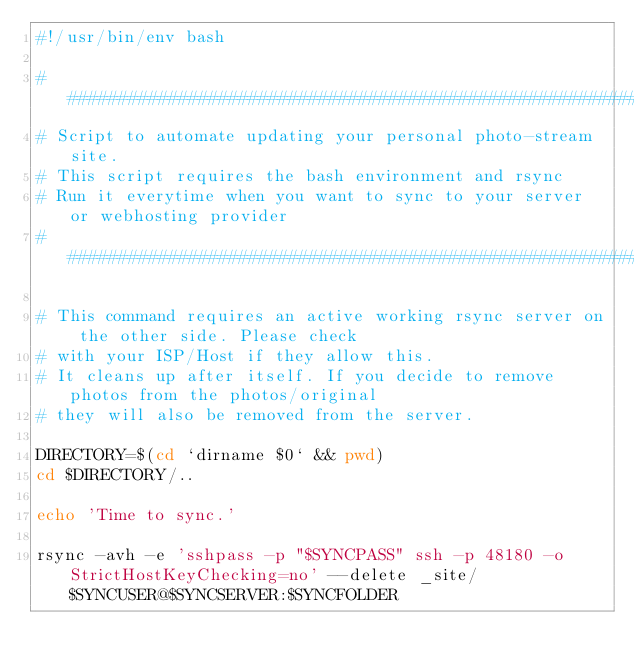<code> <loc_0><loc_0><loc_500><loc_500><_Bash_>#!/usr/bin/env bash

#####################################################################################
# Script to automate updating your personal photo-stream site.
# This script requires the bash environment and rsync
# Run it everytime when you want to sync to your server or webhosting provider
#####################################################################################

# This command requires an active working rsync server on the other side. Please check 
# with your ISP/Host if they allow this.
# It cleans up after itself. If you decide to remove photos from the photos/original
# they will also be removed from the server.

DIRECTORY=$(cd `dirname $0` && pwd)
cd $DIRECTORY/..

echo 'Time to sync.'

rsync -avh -e 'sshpass -p "$SYNCPASS" ssh -p 48180 -o StrictHostKeyChecking=no' --delete _site/ $SYNCUSER@$SYNCSERVER:$SYNCFOLDER
</code> 